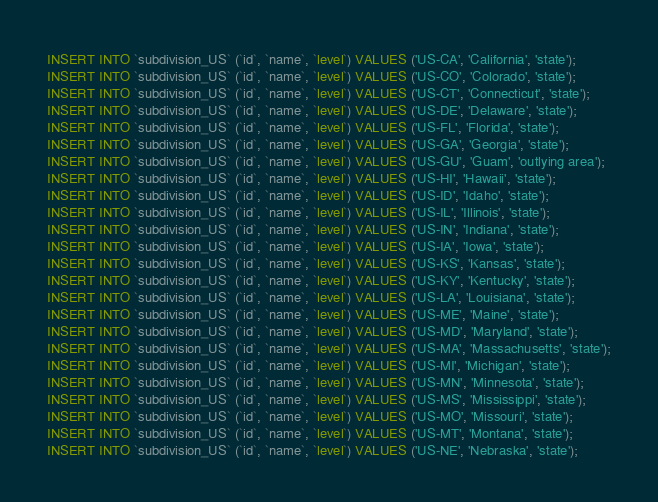Convert code to text. <code><loc_0><loc_0><loc_500><loc_500><_SQL_>INSERT INTO `subdivision_US` (`id`, `name`, `level`) VALUES ('US-CA', 'California', 'state');
INSERT INTO `subdivision_US` (`id`, `name`, `level`) VALUES ('US-CO', 'Colorado', 'state');
INSERT INTO `subdivision_US` (`id`, `name`, `level`) VALUES ('US-CT', 'Connecticut', 'state');
INSERT INTO `subdivision_US` (`id`, `name`, `level`) VALUES ('US-DE', 'Delaware', 'state');
INSERT INTO `subdivision_US` (`id`, `name`, `level`) VALUES ('US-FL', 'Florida', 'state');
INSERT INTO `subdivision_US` (`id`, `name`, `level`) VALUES ('US-GA', 'Georgia', 'state');
INSERT INTO `subdivision_US` (`id`, `name`, `level`) VALUES ('US-GU', 'Guam', 'outlying area');
INSERT INTO `subdivision_US` (`id`, `name`, `level`) VALUES ('US-HI', 'Hawaii', 'state');
INSERT INTO `subdivision_US` (`id`, `name`, `level`) VALUES ('US-ID', 'Idaho', 'state');
INSERT INTO `subdivision_US` (`id`, `name`, `level`) VALUES ('US-IL', 'Illinois', 'state');
INSERT INTO `subdivision_US` (`id`, `name`, `level`) VALUES ('US-IN', 'Indiana', 'state');
INSERT INTO `subdivision_US` (`id`, `name`, `level`) VALUES ('US-IA', 'Iowa', 'state');
INSERT INTO `subdivision_US` (`id`, `name`, `level`) VALUES ('US-KS', 'Kansas', 'state');
INSERT INTO `subdivision_US` (`id`, `name`, `level`) VALUES ('US-KY', 'Kentucky', 'state');
INSERT INTO `subdivision_US` (`id`, `name`, `level`) VALUES ('US-LA', 'Louisiana', 'state');
INSERT INTO `subdivision_US` (`id`, `name`, `level`) VALUES ('US-ME', 'Maine', 'state');
INSERT INTO `subdivision_US` (`id`, `name`, `level`) VALUES ('US-MD', 'Maryland', 'state');
INSERT INTO `subdivision_US` (`id`, `name`, `level`) VALUES ('US-MA', 'Massachusetts', 'state');
INSERT INTO `subdivision_US` (`id`, `name`, `level`) VALUES ('US-MI', 'Michigan', 'state');
INSERT INTO `subdivision_US` (`id`, `name`, `level`) VALUES ('US-MN', 'Minnesota', 'state');
INSERT INTO `subdivision_US` (`id`, `name`, `level`) VALUES ('US-MS', 'Mississippi', 'state');
INSERT INTO `subdivision_US` (`id`, `name`, `level`) VALUES ('US-MO', 'Missouri', 'state');
INSERT INTO `subdivision_US` (`id`, `name`, `level`) VALUES ('US-MT', 'Montana', 'state');
INSERT INTO `subdivision_US` (`id`, `name`, `level`) VALUES ('US-NE', 'Nebraska', 'state');</code> 